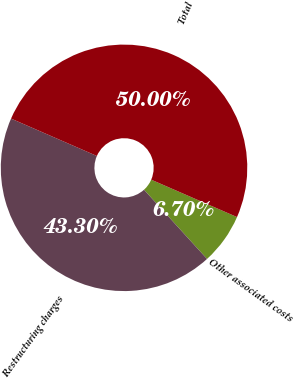Convert chart. <chart><loc_0><loc_0><loc_500><loc_500><pie_chart><fcel>Other associated costs<fcel>Restructuring charges<fcel>Total<nl><fcel>6.7%<fcel>43.3%<fcel>50.0%<nl></chart> 